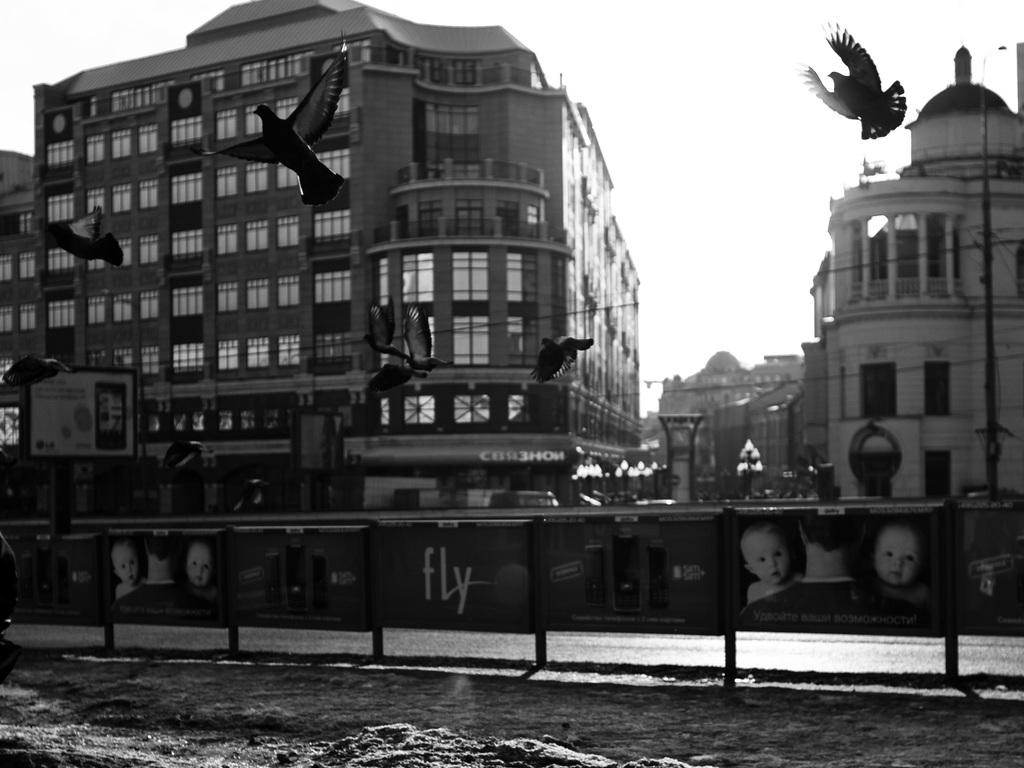What is the primary element visible in the image? There is water in the image. What type of structures can be seen in the image? There are hoardings and buildings in the image. What is happening in the sky in the image? Birds are flying in the air. What can be seen in the background of the image? There are buildings, a pole, wires, and the sky visible in the background of the image. Reasoning: Let's think step by breaking down the facts to create the conversation. We start by identifying the primary element in the image, which is the water. Then, we describe the structures and objects present in the image, such as hoardings, buildings, and the pole. Next, we mention the birds flying in the air, which adds a dynamic element to the scene. Finally, we describe the background of the image, which includes the sky, wires, and additional buildings. Absurd Question/Answer: What type of soda is being advertised on the hoardings in the image? There is no soda being advertised on the hoardings in the image; the hoardings contain other types of advertisements or information. 